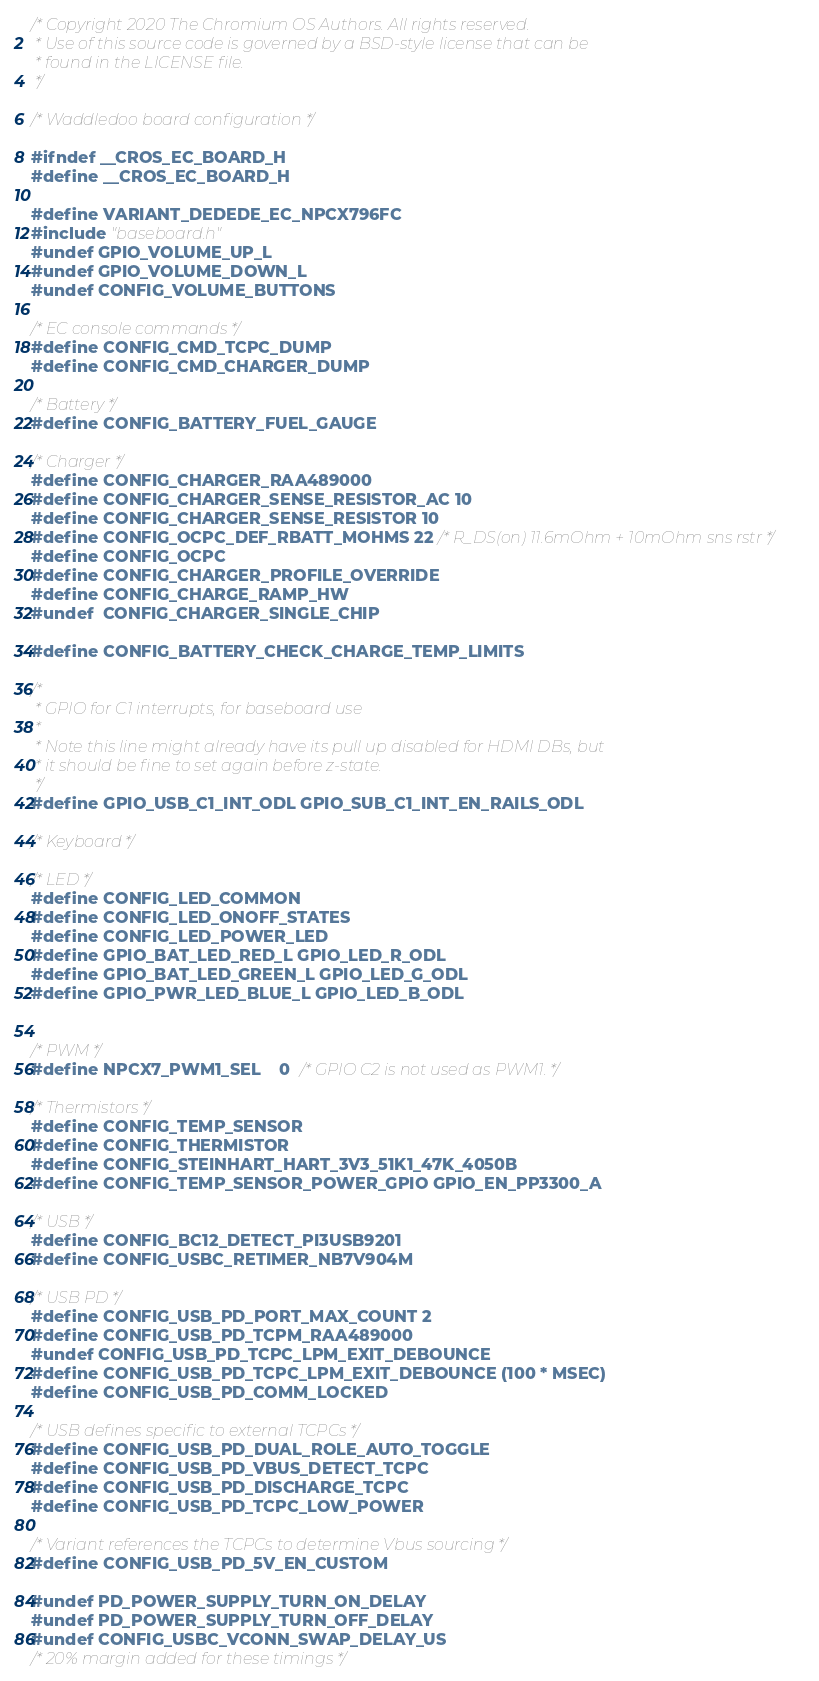Convert code to text. <code><loc_0><loc_0><loc_500><loc_500><_C_>/* Copyright 2020 The Chromium OS Authors. All rights reserved.
 * Use of this source code is governed by a BSD-style license that can be
 * found in the LICENSE file.
 */

/* Waddledoo board configuration */

#ifndef __CROS_EC_BOARD_H
#define __CROS_EC_BOARD_H

#define VARIANT_DEDEDE_EC_NPCX796FC
#include "baseboard.h"
#undef GPIO_VOLUME_UP_L
#undef GPIO_VOLUME_DOWN_L
#undef CONFIG_VOLUME_BUTTONS

/* EC console commands */
#define CONFIG_CMD_TCPC_DUMP
#define CONFIG_CMD_CHARGER_DUMP

/* Battery */
#define CONFIG_BATTERY_FUEL_GAUGE

/* Charger */
#define CONFIG_CHARGER_RAA489000
#define CONFIG_CHARGER_SENSE_RESISTOR_AC 10
#define CONFIG_CHARGER_SENSE_RESISTOR 10
#define CONFIG_OCPC_DEF_RBATT_MOHMS 22 /* R_DS(on) 11.6mOhm + 10mOhm sns rstr */
#define CONFIG_OCPC
#define CONFIG_CHARGER_PROFILE_OVERRIDE
#define CONFIG_CHARGE_RAMP_HW
#undef  CONFIG_CHARGER_SINGLE_CHIP

#define CONFIG_BATTERY_CHECK_CHARGE_TEMP_LIMITS

/*
 * GPIO for C1 interrupts, for baseboard use
 *
 * Note this line might already have its pull up disabled for HDMI DBs, but
 * it should be fine to set again before z-state.
 */
#define GPIO_USB_C1_INT_ODL GPIO_SUB_C1_INT_EN_RAILS_ODL

/* Keyboard */

/* LED */
#define CONFIG_LED_COMMON
#define CONFIG_LED_ONOFF_STATES
#define CONFIG_LED_POWER_LED
#define GPIO_BAT_LED_RED_L GPIO_LED_R_ODL
#define GPIO_BAT_LED_GREEN_L GPIO_LED_G_ODL
#define GPIO_PWR_LED_BLUE_L GPIO_LED_B_ODL


/* PWM */
#define NPCX7_PWM1_SEL    0  /* GPIO C2 is not used as PWM1. */

/* Thermistors */
#define CONFIG_TEMP_SENSOR
#define CONFIG_THERMISTOR
#define CONFIG_STEINHART_HART_3V3_51K1_47K_4050B
#define CONFIG_TEMP_SENSOR_POWER_GPIO GPIO_EN_PP3300_A

/* USB */
#define CONFIG_BC12_DETECT_PI3USB9201
#define CONFIG_USBC_RETIMER_NB7V904M

/* USB PD */
#define CONFIG_USB_PD_PORT_MAX_COUNT 2
#define CONFIG_USB_PD_TCPM_RAA489000
#undef CONFIG_USB_PD_TCPC_LPM_EXIT_DEBOUNCE
#define CONFIG_USB_PD_TCPC_LPM_EXIT_DEBOUNCE (100 * MSEC)
#define CONFIG_USB_PD_COMM_LOCKED

/* USB defines specific to external TCPCs */
#define CONFIG_USB_PD_DUAL_ROLE_AUTO_TOGGLE
#define CONFIG_USB_PD_VBUS_DETECT_TCPC
#define CONFIG_USB_PD_DISCHARGE_TCPC
#define CONFIG_USB_PD_TCPC_LOW_POWER

/* Variant references the TCPCs to determine Vbus sourcing */
#define CONFIG_USB_PD_5V_EN_CUSTOM

#undef PD_POWER_SUPPLY_TURN_ON_DELAY
#undef PD_POWER_SUPPLY_TURN_OFF_DELAY
#undef CONFIG_USBC_VCONN_SWAP_DELAY_US
/* 20% margin added for these timings */</code> 